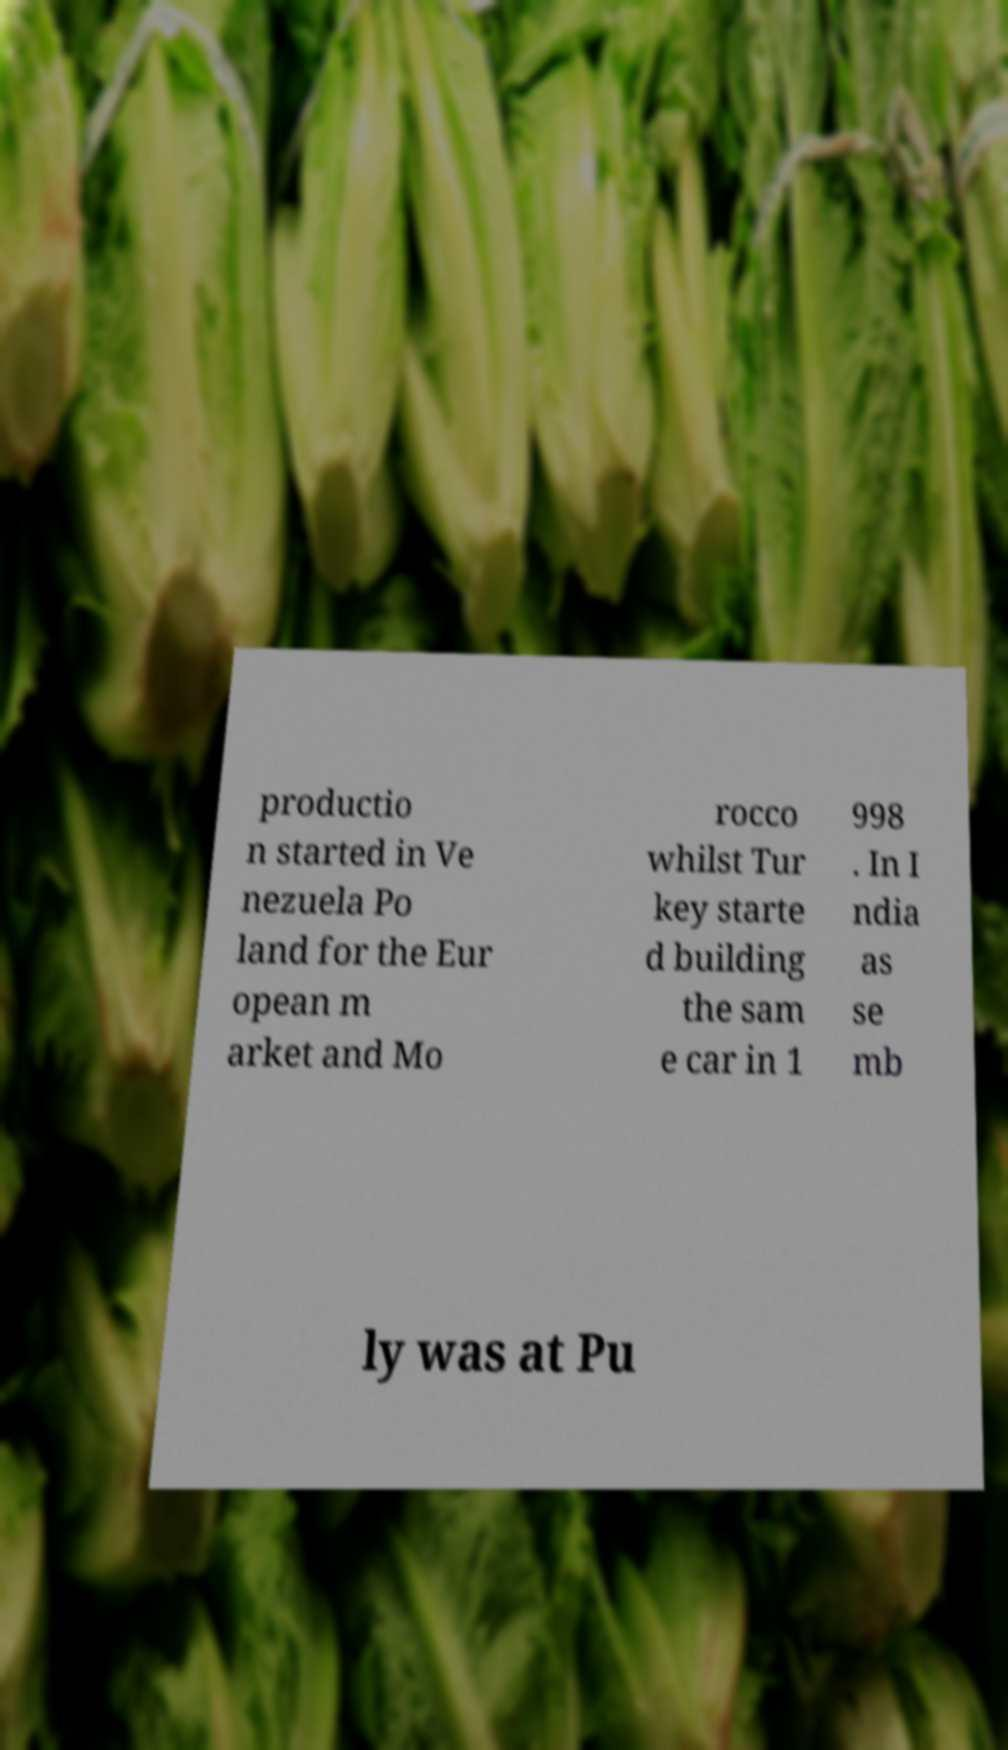Can you read and provide the text displayed in the image?This photo seems to have some interesting text. Can you extract and type it out for me? productio n started in Ve nezuela Po land for the Eur opean m arket and Mo rocco whilst Tur key starte d building the sam e car in 1 998 . In I ndia as se mb ly was at Pu 